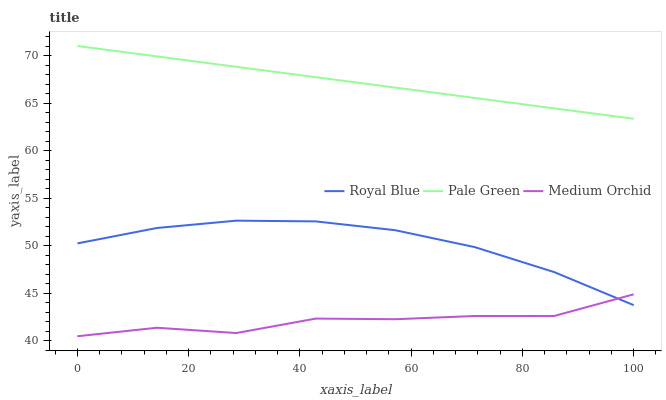Does Medium Orchid have the minimum area under the curve?
Answer yes or no. Yes. Does Pale Green have the maximum area under the curve?
Answer yes or no. Yes. Does Pale Green have the minimum area under the curve?
Answer yes or no. No. Does Medium Orchid have the maximum area under the curve?
Answer yes or no. No. Is Pale Green the smoothest?
Answer yes or no. Yes. Is Medium Orchid the roughest?
Answer yes or no. Yes. Is Medium Orchid the smoothest?
Answer yes or no. No. Is Pale Green the roughest?
Answer yes or no. No. Does Medium Orchid have the lowest value?
Answer yes or no. Yes. Does Pale Green have the lowest value?
Answer yes or no. No. Does Pale Green have the highest value?
Answer yes or no. Yes. Does Medium Orchid have the highest value?
Answer yes or no. No. Is Royal Blue less than Pale Green?
Answer yes or no. Yes. Is Pale Green greater than Royal Blue?
Answer yes or no. Yes. Does Royal Blue intersect Medium Orchid?
Answer yes or no. Yes. Is Royal Blue less than Medium Orchid?
Answer yes or no. No. Is Royal Blue greater than Medium Orchid?
Answer yes or no. No. Does Royal Blue intersect Pale Green?
Answer yes or no. No. 